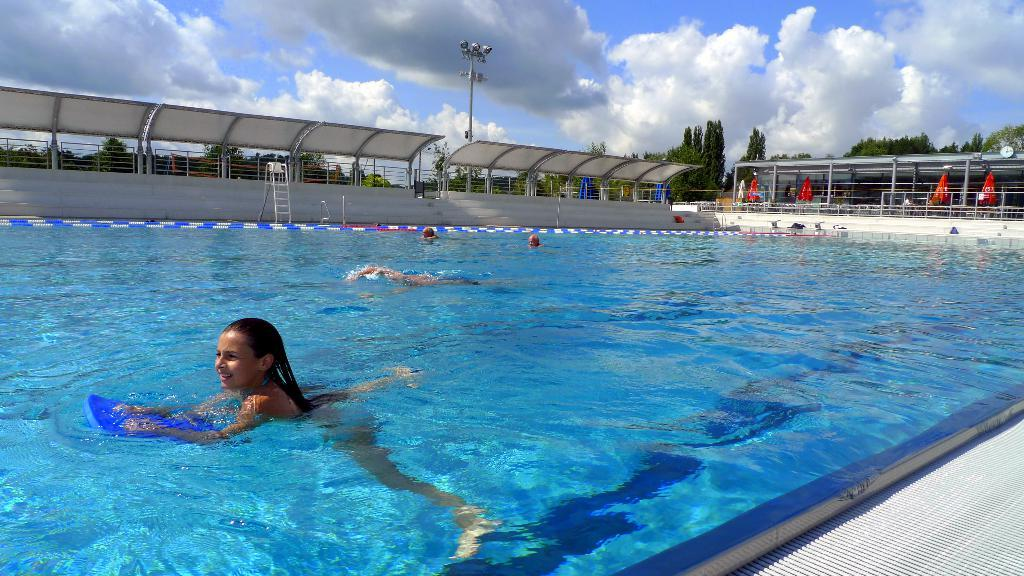How many people are in the image? There is a group of people in the image. What are the people doing in the image? The people are swimming in a pool. Can you describe any architectural features in the image? Yes, there are stairs in the image. What can be seen in the background of the image? There are trees and the sky visible in the background of the image. What is the weather like in the image? The sky appears to be sunny, suggesting a clear and bright day. What type of chalk is being used to draw on the steel surface in the image? There is no chalk or steel surface present in the image; it features a group of people swimming in a pool. What time of day is depicted in the image, given the presence of night? The image does not depict night; the sky appears to be sunny, suggesting a daytime scene. 